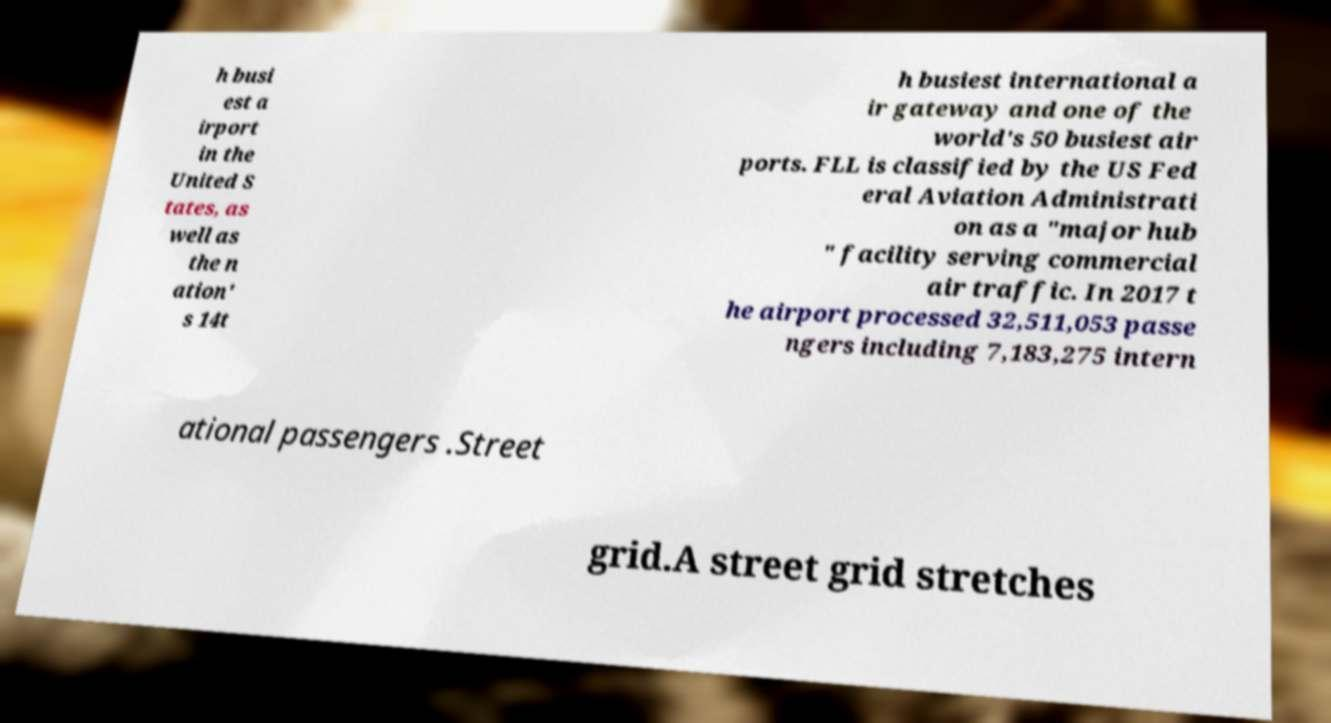What messages or text are displayed in this image? I need them in a readable, typed format. h busi est a irport in the United S tates, as well as the n ation' s 14t h busiest international a ir gateway and one of the world's 50 busiest air ports. FLL is classified by the US Fed eral Aviation Administrati on as a "major hub " facility serving commercial air traffic. In 2017 t he airport processed 32,511,053 passe ngers including 7,183,275 intern ational passengers .Street grid.A street grid stretches 